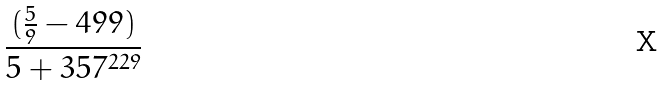Convert formula to latex. <formula><loc_0><loc_0><loc_500><loc_500>\frac { ( \frac { 5 } { 9 } - 4 9 9 ) } { 5 + 3 5 7 ^ { 2 2 9 } }</formula> 